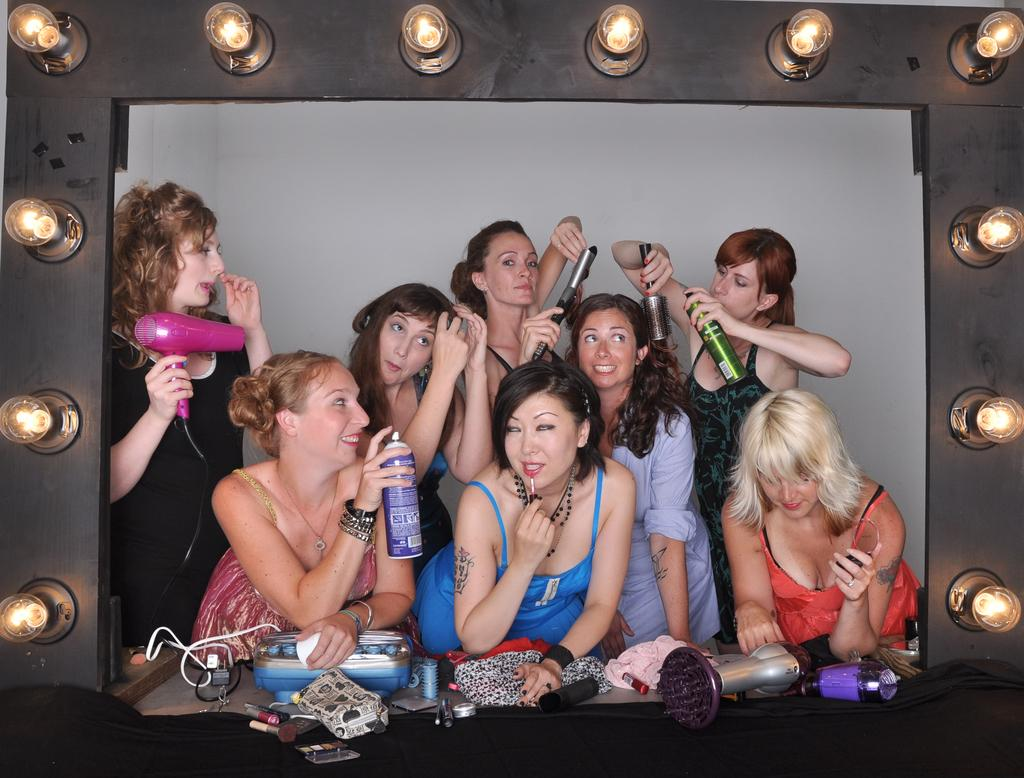How many people are in the image? There is a group of people in the image. What are two people holding in the image? Two people are holding spray bottles. What is the woman holding in the image? The woman is holding a hair dryer. What else can be seen in the image besides the people and their objects? There are objects and lights visible in the image. What type of metal is used to make the payment in the image? There is no payment being made in the image, so the type of metal used is not relevant. 